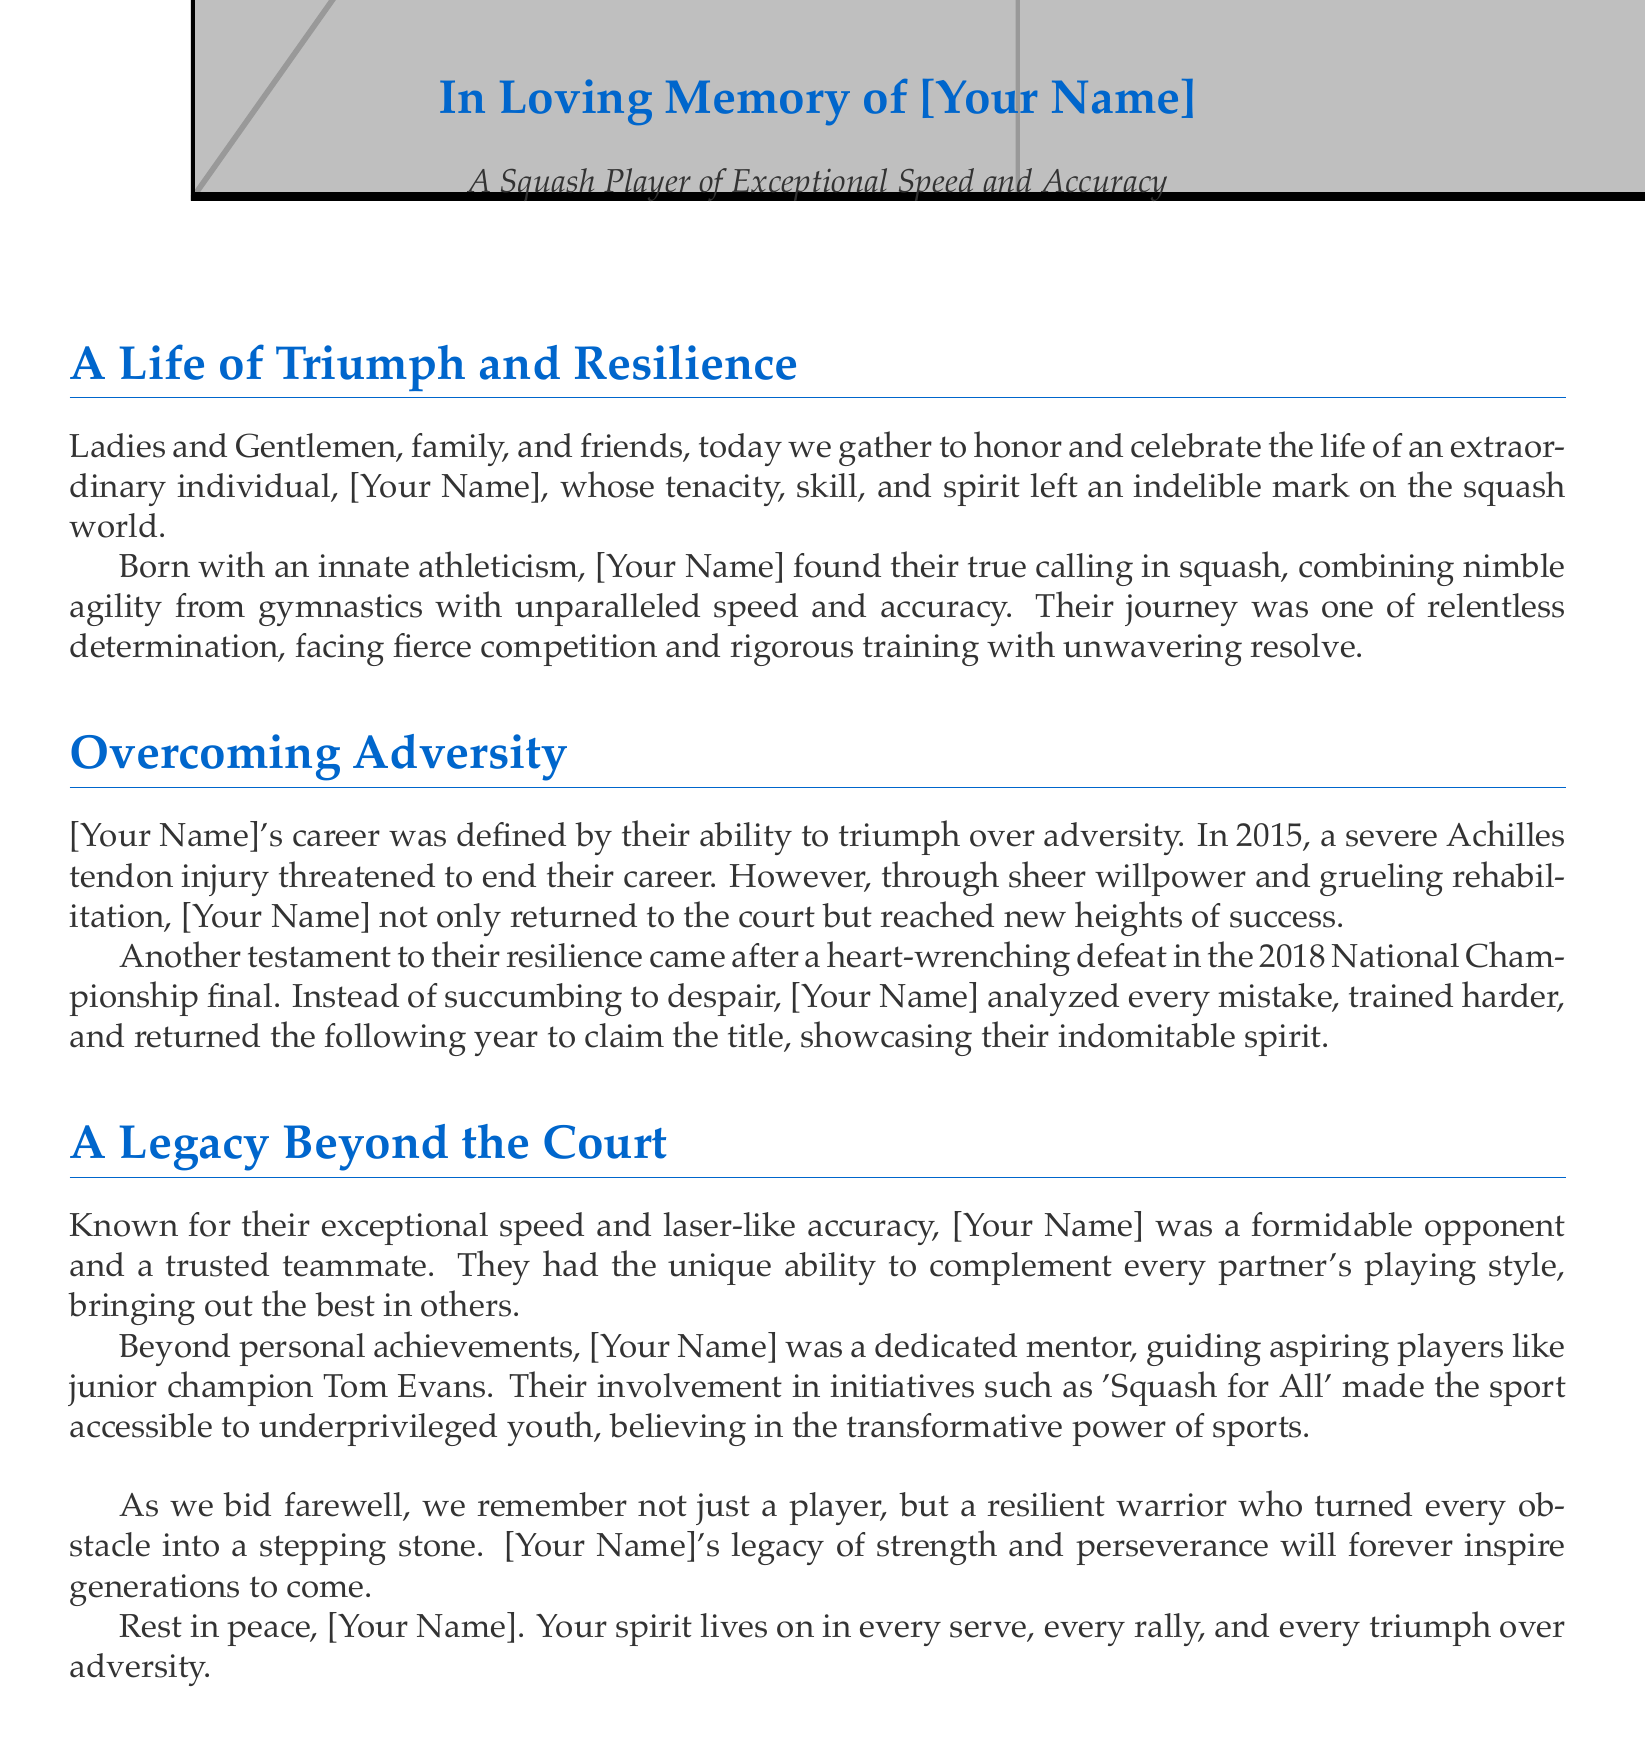What year did [Your Name] face a severe injury? The document states that the severe Achilles tendon injury occurred in 2015.
Answer: 2015 What championship did [Your Name] compete in during 2018? The document mentions that [Your Name] competed in the National Championship final in 2018.
Answer: National Championship What title did [Your Name] claim after returning from their defeat? The text indicates that [Your Name] returned the following year to claim the title after the defeat.
Answer: The title Who was mentored by [Your Name]? The eulogy notes that junior champion Tom Evans was guided by [Your Name].
Answer: Tom Evans Which initiative did [Your Name] support to help underprivileged youth? The document mentions involvement in the initiative 'Squash for All'.
Answer: Squash for All What qualities distinguished [Your Name] as a player? The eulogy refers to [Your Name]'s exceptional speed and laser-like accuracy.
Answer: Speed and accuracy What was [Your Name]'s characteristic playing style? The document describes [Your Name] as combining nimble agility from gymnastics with unparalleled speed and accuracy.
Answer: Nimble agility and speed What should we remember [Your Name] as, according to the eulogy? The conclusion emphasizes remembering [Your Name] as a resilient warrior.
Answer: A resilient warrior 